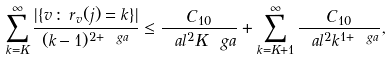<formula> <loc_0><loc_0><loc_500><loc_500>\sum _ { k = K } ^ { \infty } \frac { | \{ v \, \colon \, r _ { v } ( j ) = k \} | } { ( k - 1 ) ^ { 2 + \ g a } } \leq \frac { C _ { 1 0 } } { \ a l ^ { 2 } K ^ { \ } g a } + \sum _ { k = K + 1 } ^ { \infty } \frac { C _ { 1 0 } } { \ a l ^ { 2 } k ^ { 1 + \ g a } } ,</formula> 